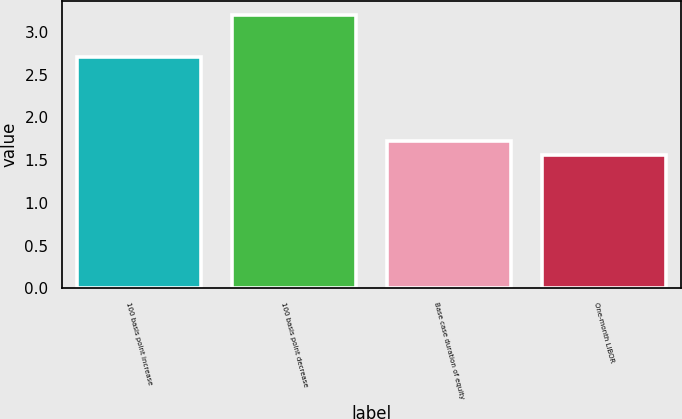Convert chart to OTSL. <chart><loc_0><loc_0><loc_500><loc_500><bar_chart><fcel>100 basis point increase<fcel>100 basis point decrease<fcel>Base case duration of equity<fcel>One-month LIBOR<nl><fcel>2.7<fcel>3.2<fcel>1.72<fcel>1.56<nl></chart> 